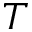Convert formula to latex. <formula><loc_0><loc_0><loc_500><loc_500>T</formula> 